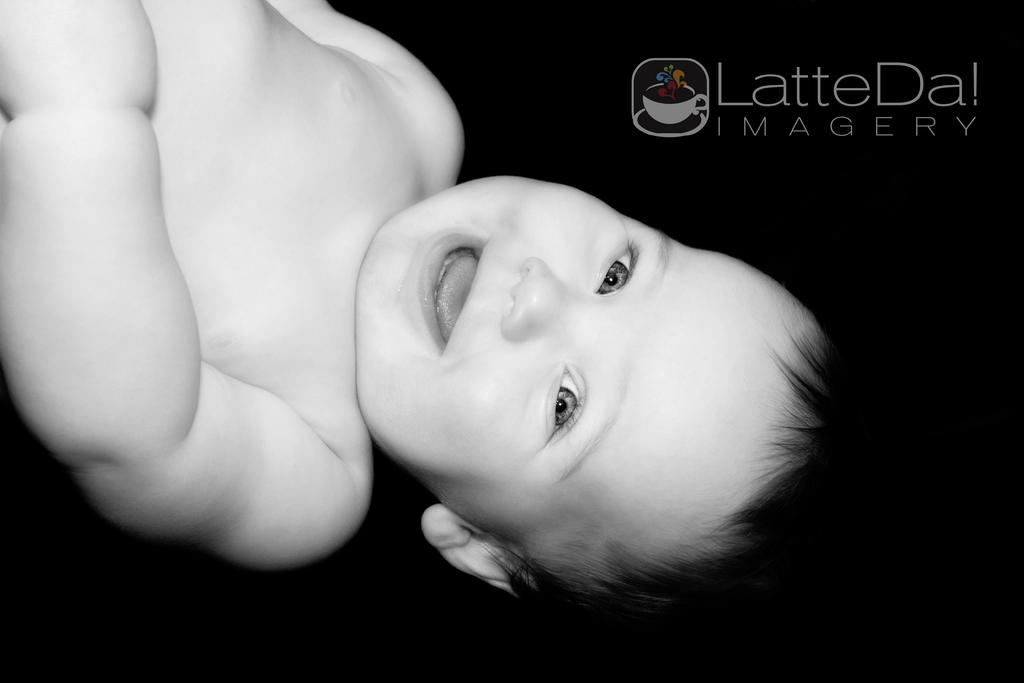What type of editing has been done to the image? The image is edited, but the specific type of editing is not mentioned in the facts. What is the main subject of the image? There is a black and white picture of a baby in the image. How is the baby positioned in the image? The background of the baby is dark. What additional information is present in the image? There is some text at the top right corner of the image. What type of wine is being served in the image? There is no wine present in the image; it features a black and white picture of a baby with a dark background and some text at the top right corner. 